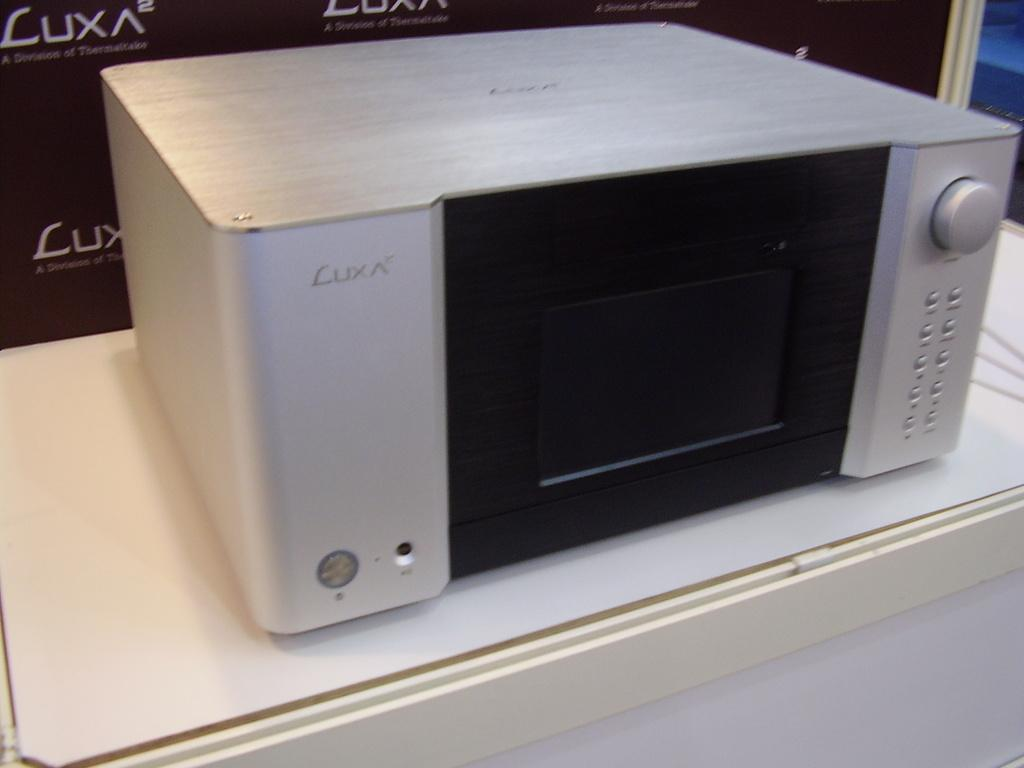<image>
Offer a succinct explanation of the picture presented. A Luxa brand electronic device is on a white table 